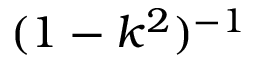Convert formula to latex. <formula><loc_0><loc_0><loc_500><loc_500>( 1 - k ^ { 2 } ) ^ { - 1 }</formula> 